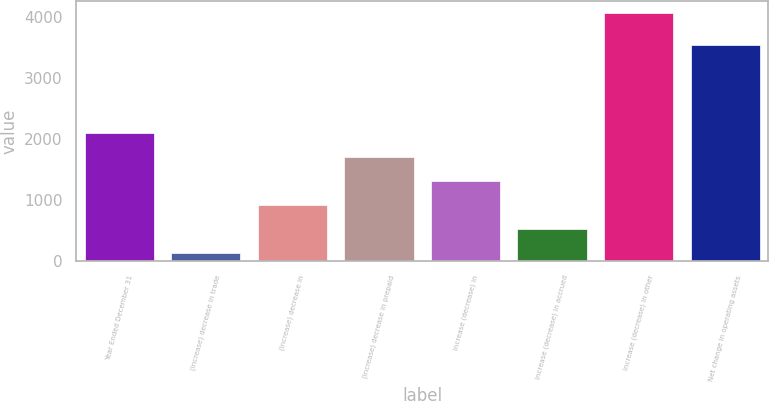Convert chart. <chart><loc_0><loc_0><loc_500><loc_500><bar_chart><fcel>Year Ended December 31<fcel>(Increase) decrease in trade<fcel>(Increase) decrease in<fcel>(Increase) decrease in prepaid<fcel>Increase (decrease) in<fcel>Increase (decrease) in accrued<fcel>Increase (decrease) in other<fcel>Net change in operating assets<nl><fcel>2096.5<fcel>141<fcel>923.2<fcel>1705.4<fcel>1314.3<fcel>532.1<fcel>4052<fcel>3529<nl></chart> 